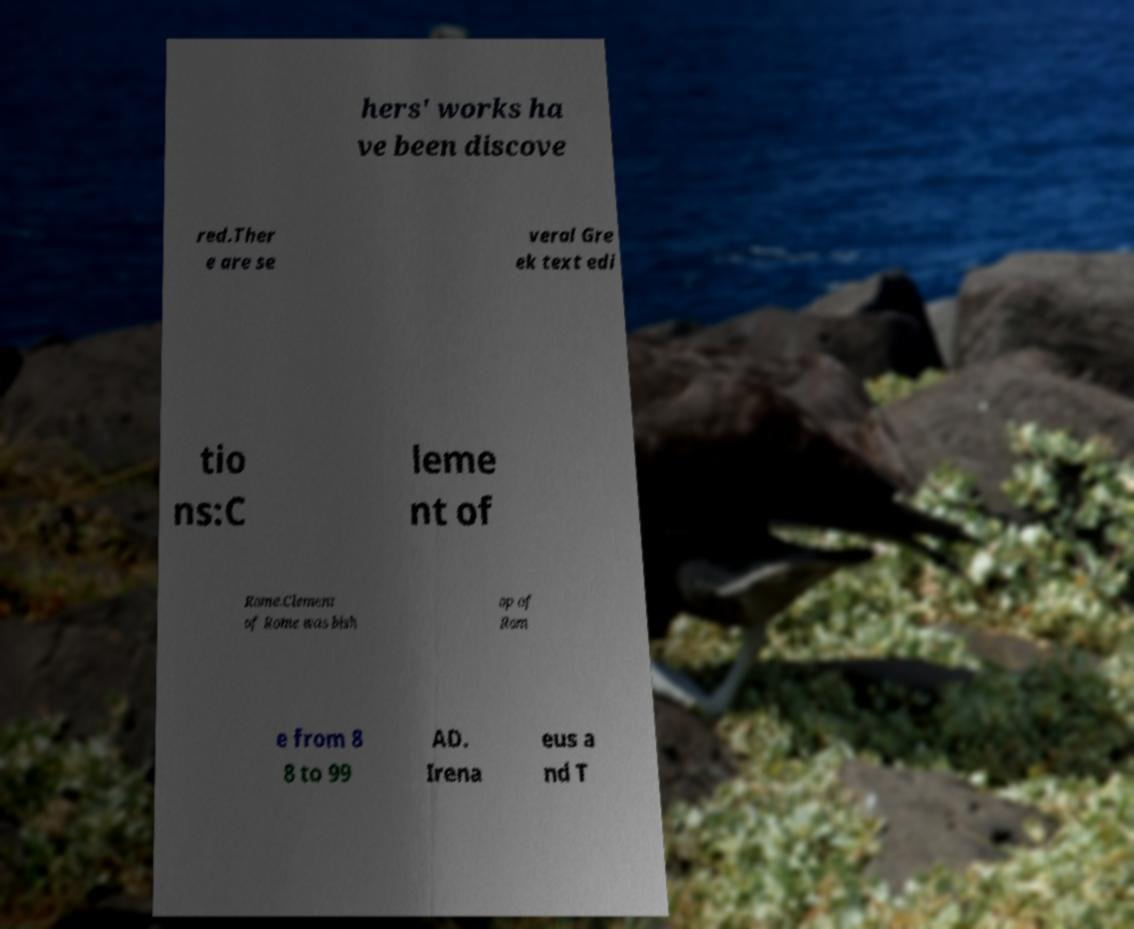There's text embedded in this image that I need extracted. Can you transcribe it verbatim? hers' works ha ve been discove red.Ther e are se veral Gre ek text edi tio ns:C leme nt of Rome.Clement of Rome was bish op of Rom e from 8 8 to 99 AD. Irena eus a nd T 